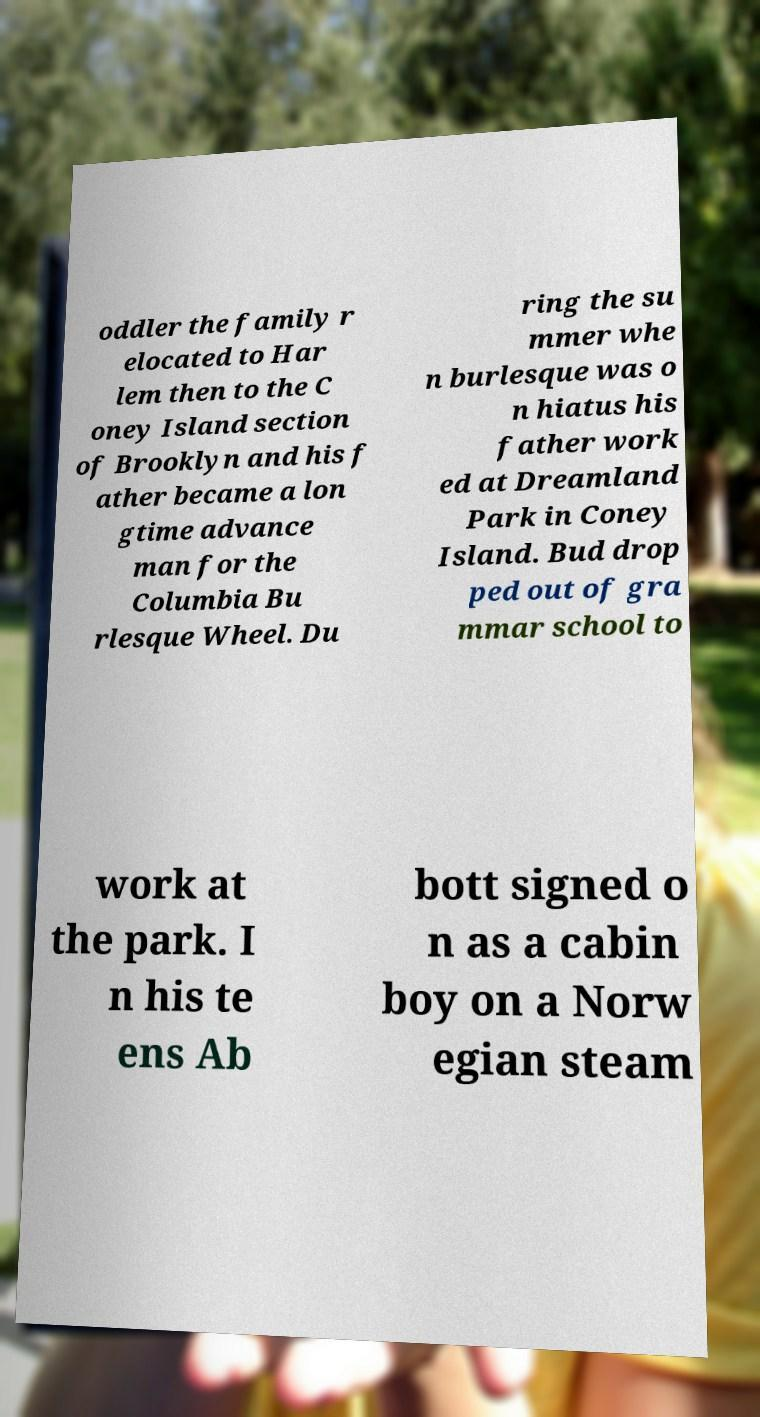I need the written content from this picture converted into text. Can you do that? oddler the family r elocated to Har lem then to the C oney Island section of Brooklyn and his f ather became a lon gtime advance man for the Columbia Bu rlesque Wheel. Du ring the su mmer whe n burlesque was o n hiatus his father work ed at Dreamland Park in Coney Island. Bud drop ped out of gra mmar school to work at the park. I n his te ens Ab bott signed o n as a cabin boy on a Norw egian steam 